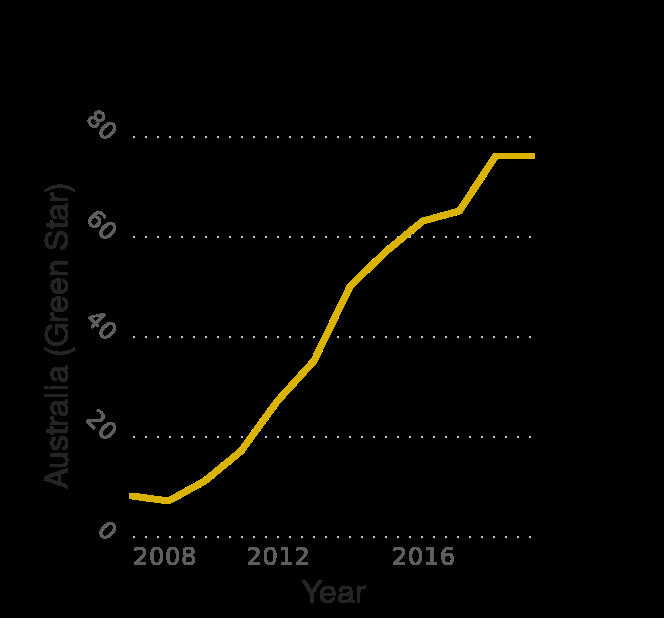<image>
What is the range on the x-axis for the years covered in the line plot?  The range on the x-axis is from 2008 to 2018, representing the years during which the green building certified projects were constructed by Hochtief. Offer a thorough analysis of the image. From 2008 and 2019 the number of green certified projects has increased in number every year. Every 4 years the number of green projects doubles with the years after 2016 being the exception. After the year 2016 the number increased more than any other year. The years 2018 to 2019 showed no increase and no loss. What does the line plot indicate about the progress of Hochtief's green building certifications over time? The line plot provides an overview of Hochtief's progress in obtaining green building certifications in Australia (Green Star) from 2008 to 2018, showcasing any increases or decreases in the number of certified projects. What type of certification does the y-axis represent in the line plot?  The y-axis represents the type of certification achieved, specifically Green Star certification in Australia. 